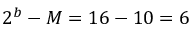<formula> <loc_0><loc_0><loc_500><loc_500>2 ^ { b } - M = 1 6 - 1 0 = 6</formula> 